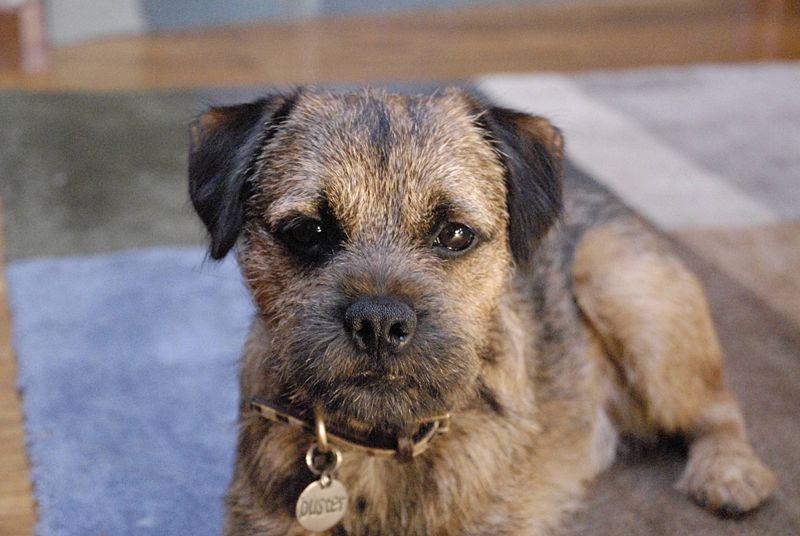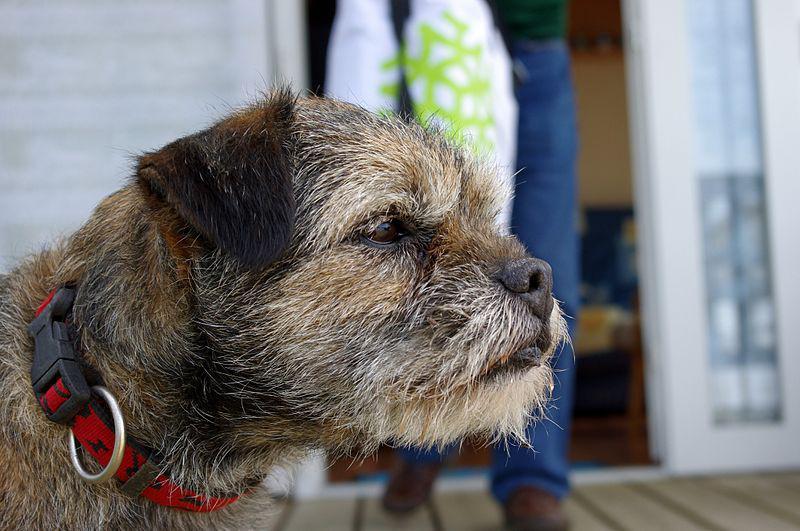The first image is the image on the left, the second image is the image on the right. Evaluate the accuracy of this statement regarding the images: "A medallion can be seen hanging from the collar of the dog in the image on the left.". Is it true? Answer yes or no. Yes. 